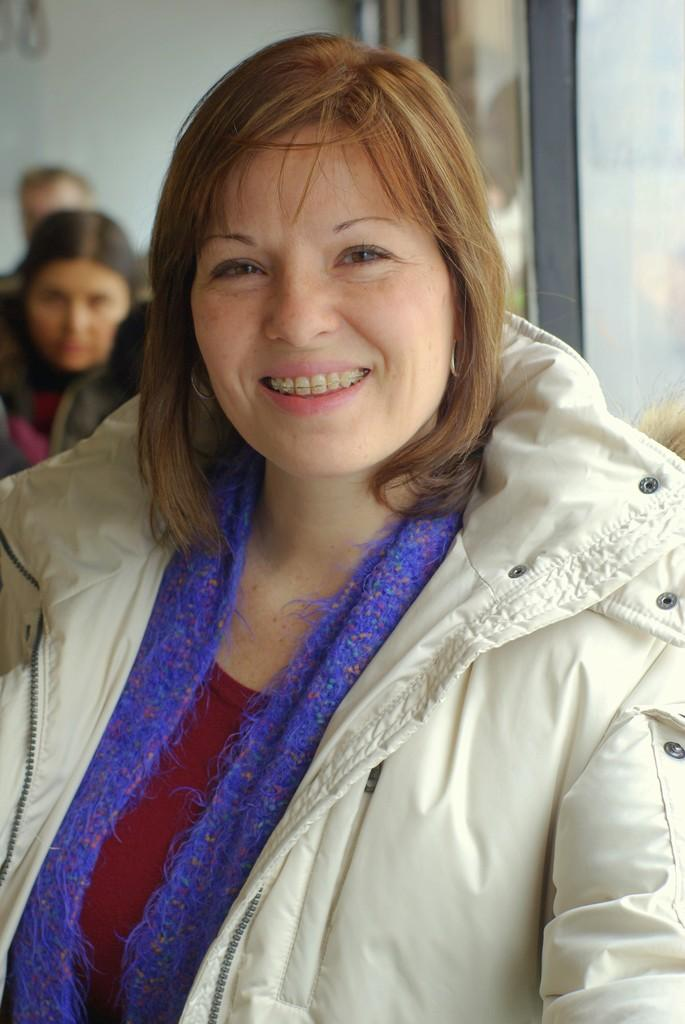Who is present in the image? There is a woman in the image. What is the woman's facial expression? The woman is smiling. What can be seen in the background of the image? There are people, a wall, and a glass object in the background of the image. How many sheep are visible in the image? There are no sheep present in the image. What type of bun is the woman holding in the image? There is no bun present in the image. 